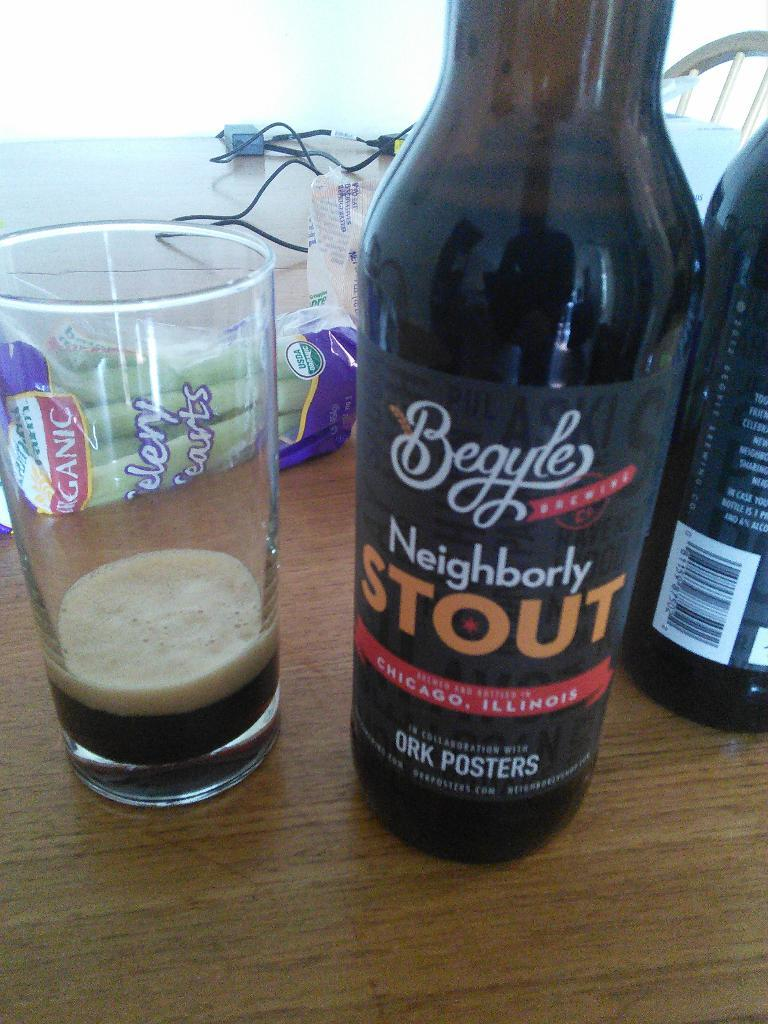<image>
Give a short and clear explanation of the subsequent image. A bottle is labeled Neighborly Stout and is next to a glass that is almost empty. 